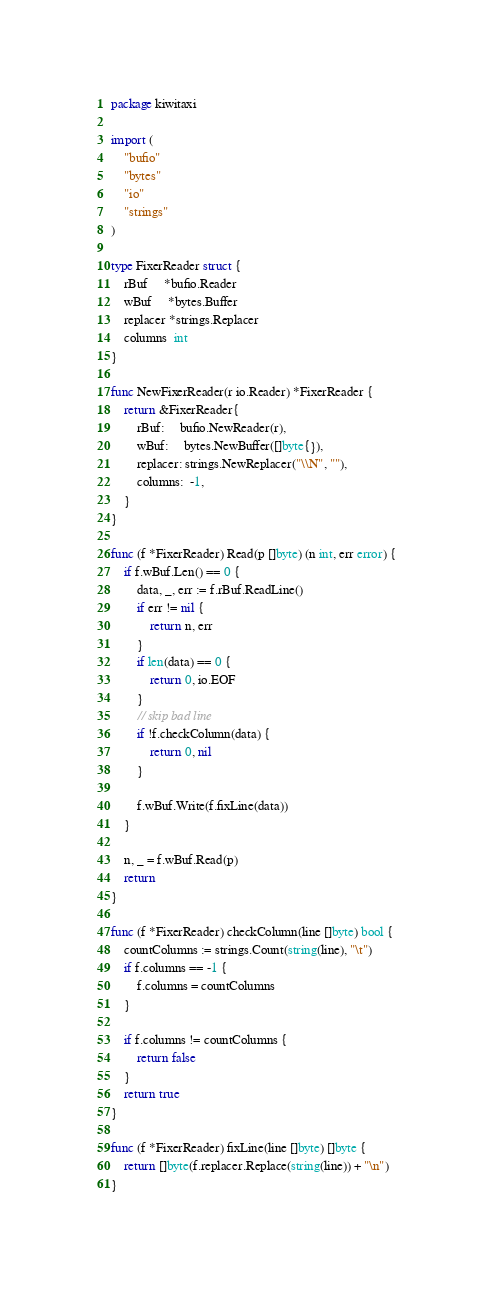Convert code to text. <code><loc_0><loc_0><loc_500><loc_500><_Go_>package kiwitaxi

import (
	"bufio"
	"bytes"
	"io"
	"strings"
)

type FixerReader struct {
	rBuf     *bufio.Reader
	wBuf     *bytes.Buffer
	replacer *strings.Replacer
	columns  int
}

func NewFixerReader(r io.Reader) *FixerReader {
	return &FixerReader{
		rBuf:     bufio.NewReader(r),
		wBuf:     bytes.NewBuffer([]byte{}),
		replacer: strings.NewReplacer("\\N", ""),
		columns:  -1,
	}
}

func (f *FixerReader) Read(p []byte) (n int, err error) {
	if f.wBuf.Len() == 0 {
		data, _, err := f.rBuf.ReadLine()
		if err != nil {
			return n, err
		}
		if len(data) == 0 {
			return 0, io.EOF
		}
		// skip bad line
		if !f.checkColumn(data) {
			return 0, nil
		}

		f.wBuf.Write(f.fixLine(data))
	}

	n, _ = f.wBuf.Read(p)
	return
}

func (f *FixerReader) checkColumn(line []byte) bool {
	countColumns := strings.Count(string(line), "\t")
	if f.columns == -1 {
		f.columns = countColumns
	}

	if f.columns != countColumns {
		return false
	}
	return true
}

func (f *FixerReader) fixLine(line []byte) []byte {
	return []byte(f.replacer.Replace(string(line)) + "\n")
}
</code> 